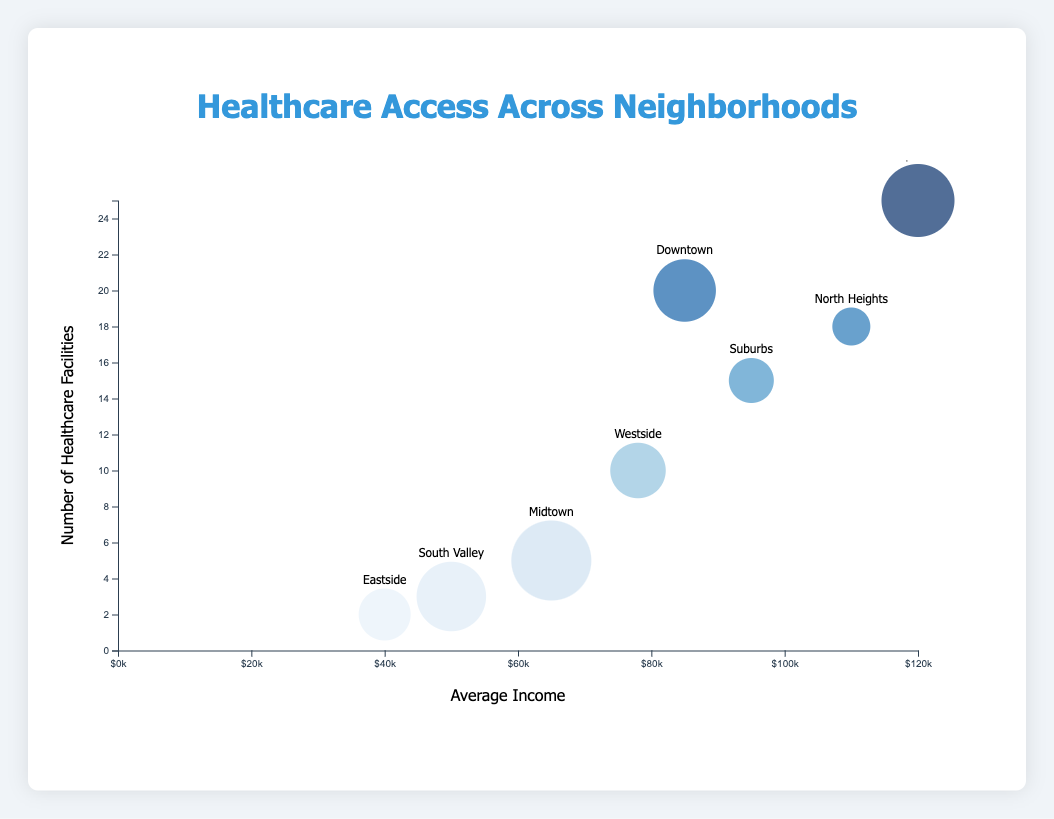What's the title of the chart? The title of the chart is displayed at the top of the figure.
Answer: Healthcare Access Across Neighborhoods Which axis shows average income? The average income is represented on the horizontal axis, as indicated by the label.
Answer: The horizontal axis Which neighborhood has the fewest healthcare facilities? By examining the number of healthcare facilities on the vertical axis, the neighborhood with the lowest value is Eastside.
Answer: Eastside Which neighborhood has the highest average income? According to the horizontal axis representing average income, Uptown has the highest value.
Answer: Uptown What is the population size for Midtown? The size of the bubble indicates the population size. Midtown's bubble size is shown in the tooltip when hovering over the bubble.
Answer: 20000 Compare the number of healthcare facilities in Uptown and Eastside. Which has more? Refer to the vertical axis for the number of healthcare facilities. Uptown has 25 and Eastside has 2.
Answer: Uptown What is the total number of healthcare facilities in Downtown, Suburbs, and North Heights? Sum the number of healthcare facilities in these neighborhoods: Downtown (20) + Suburbs (15) + North Heights (18).
Answer: 53 Is there a correlation between average income and the number of healthcare facilities? Generally, as the average income increases, there are more healthcare facilities visible from the chart, showing a positive correlation.
Answer: Positive correlation Which neighborhood has the largest population? The largest bubble indicates the largest population. By observing all bubbles, Midtown stands out.
Answer: Midtown 